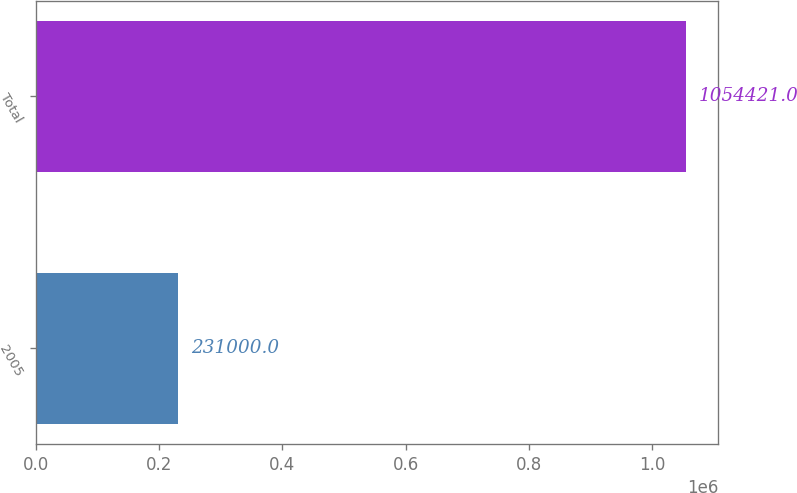Convert chart. <chart><loc_0><loc_0><loc_500><loc_500><bar_chart><fcel>2005<fcel>Total<nl><fcel>231000<fcel>1.05442e+06<nl></chart> 